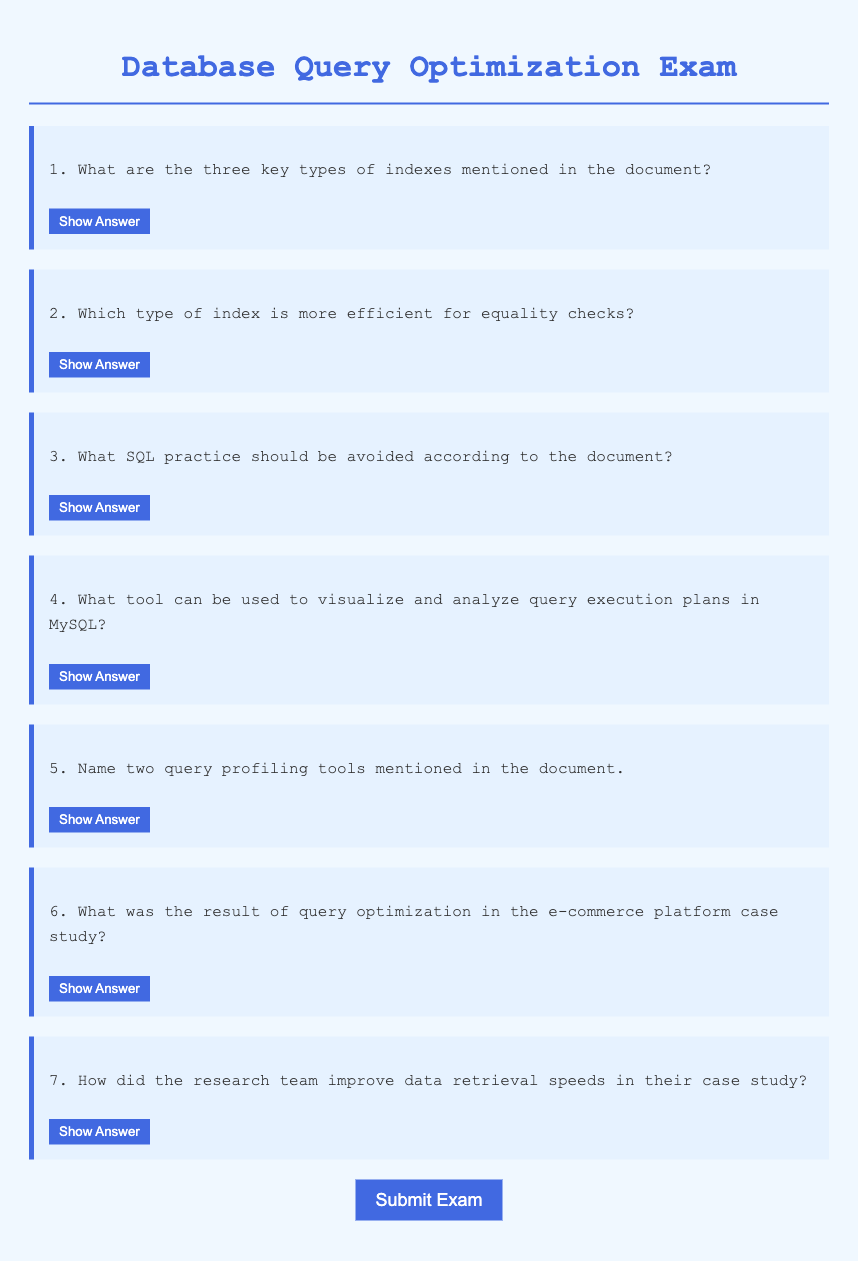What are the three key types of indexes? The document mentions that B-tree, hash, and bitmap indexes are the three key types of indexes.
Answer: B-tree, hash, and bitmap indexes Which index type is used for equality checks? The document specifies that hash indexes are more efficient for equality checks.
Answer: Hash indexes What SQL practice should be avoided? According to the document, avoiding SELECT * and instead specifying the required columns should be avoided.
Answer: Avoiding SELECT *, instead specifying the required columns What tool visualizes query execution plans in MySQL? The document states that the EXPLAIN tool can be used to visualize and analyze query execution plans in MySQL.
Answer: EXPLAIN What was the outcome of the e-commerce platform optimization? The document indicates that there was a 50% reduction in query response times as a result of the optimization.
Answer: 50% reduction in query response times How were data retrieval speeds improved in the case study? The improvement in data retrieval speeds was achieved by using partitioning strategies and analyzing query execution plans.
Answer: By using partitioning strategies and analyzing query execution plans 